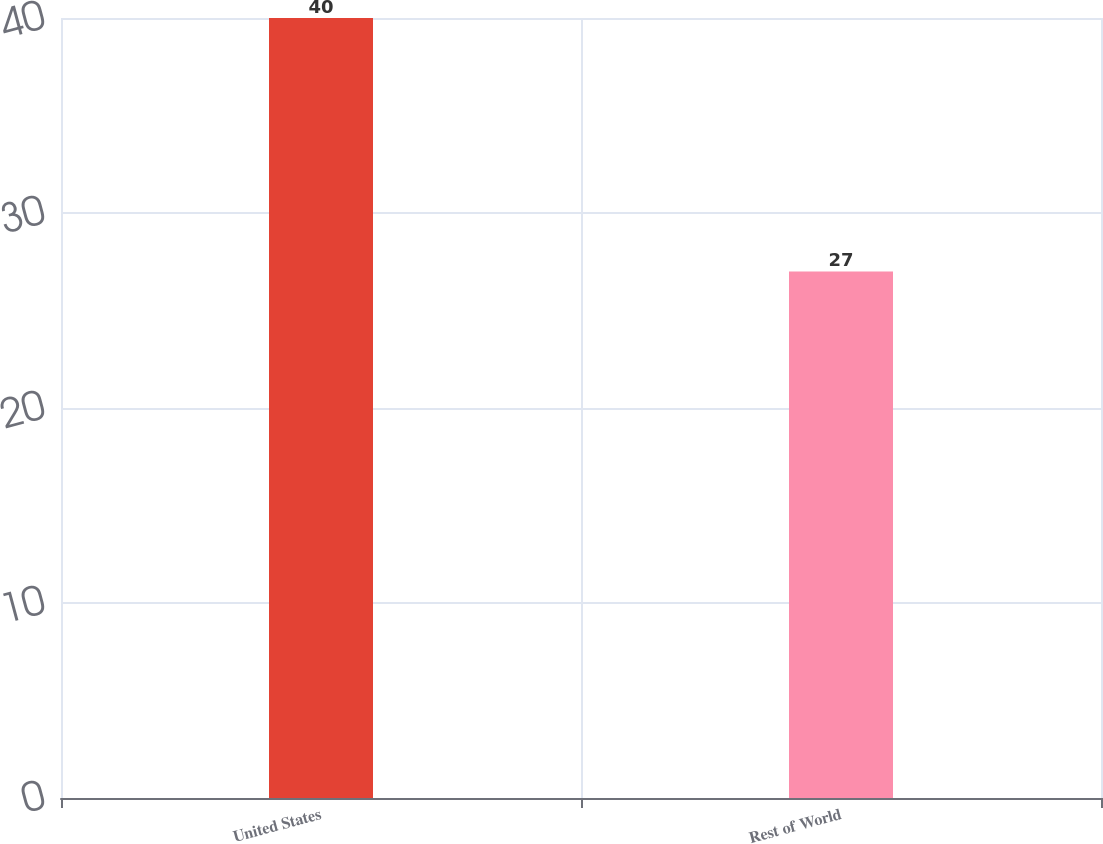Convert chart to OTSL. <chart><loc_0><loc_0><loc_500><loc_500><bar_chart><fcel>United States<fcel>Rest of World<nl><fcel>40<fcel>27<nl></chart> 